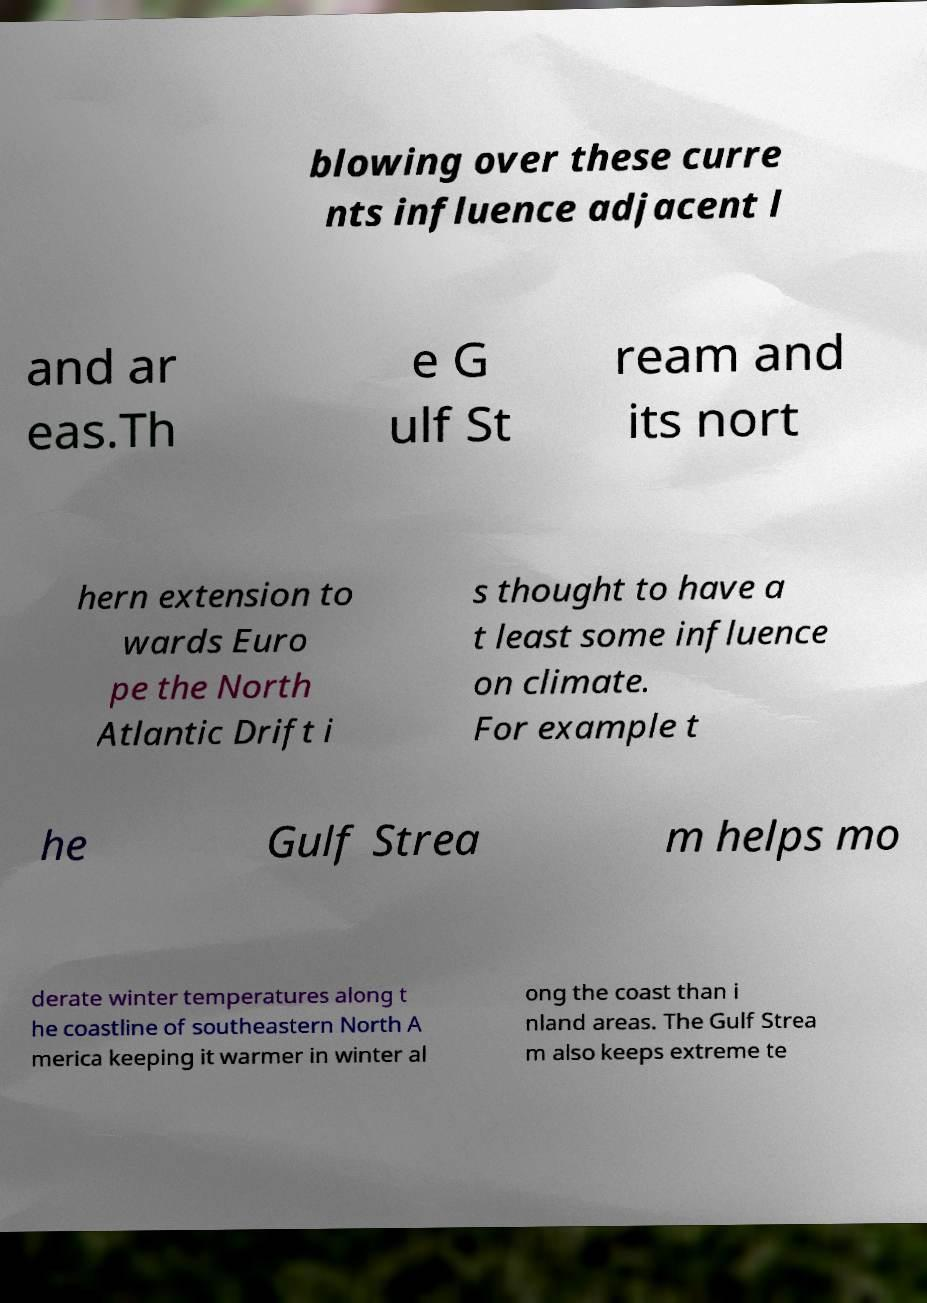I need the written content from this picture converted into text. Can you do that? blowing over these curre nts influence adjacent l and ar eas.Th e G ulf St ream and its nort hern extension to wards Euro pe the North Atlantic Drift i s thought to have a t least some influence on climate. For example t he Gulf Strea m helps mo derate winter temperatures along t he coastline of southeastern North A merica keeping it warmer in winter al ong the coast than i nland areas. The Gulf Strea m also keeps extreme te 